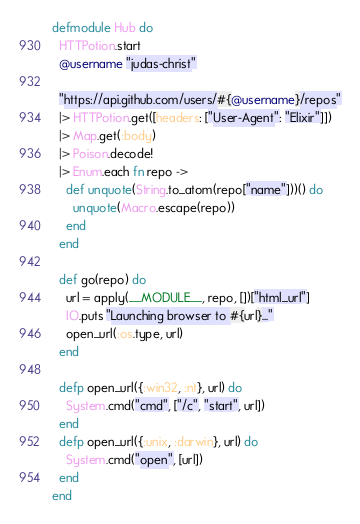<code> <loc_0><loc_0><loc_500><loc_500><_Elixir_>defmodule Hub do
  HTTPotion.start
  @username "judas-christ"

  "https://api.github.com/users/#{@username}/repos"
  |> HTTPotion.get([headers: ["User-Agent": "Elixir"]])
  |> Map.get(:body)
  |> Poison.decode!
  |> Enum.each fn repo ->
    def unquote(String.to_atom(repo["name"]))() do
      unquote(Macro.escape(repo))
    end
  end

  def go(repo) do
    url = apply(__MODULE__, repo, [])["html_url"]
    IO.puts "Launching browser to #{url}..."
    open_url(:os.type, url)
  end

  defp open_url({:win32, :nt}, url) do
    System.cmd("cmd", ["/c", "start", url])
  end
  defp open_url({:unix, :darwin}, url) do
    System.cmd("open", [url])
  end
end


</code> 